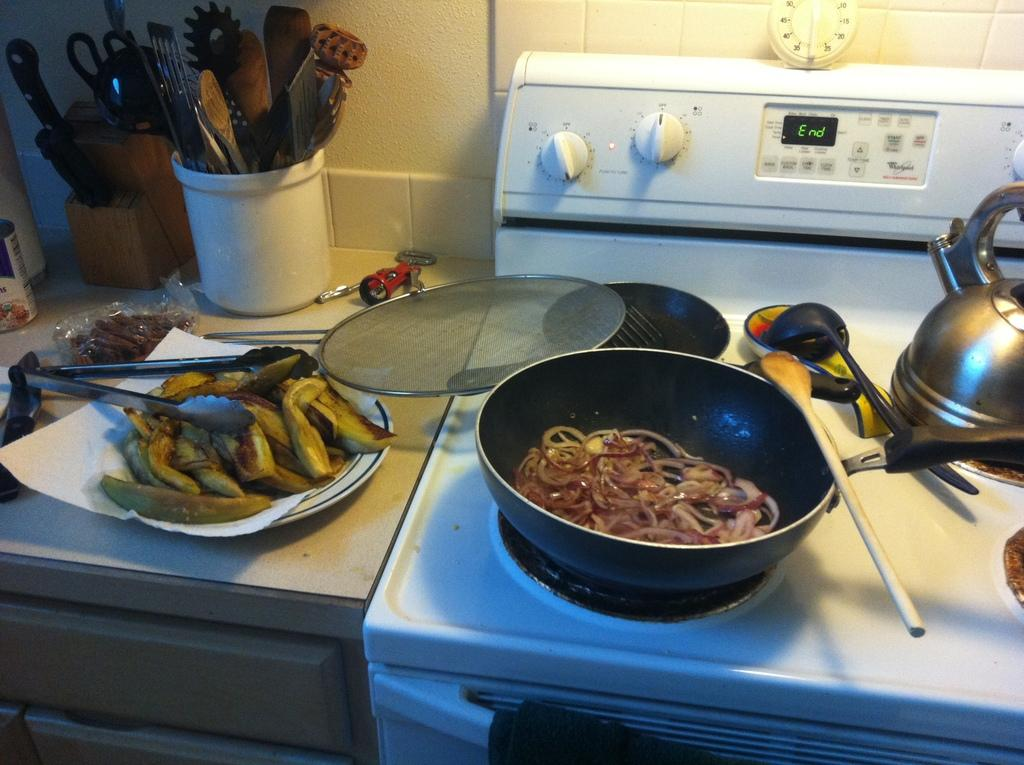<image>
Share a concise interpretation of the image provided. The digital display on the oven has the word "end" on it. 